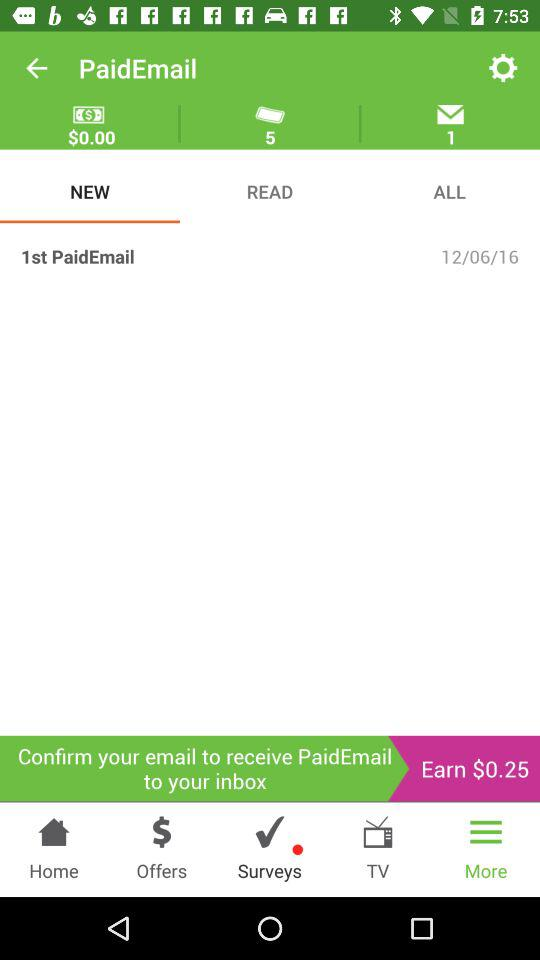When was the first paid email sent? The first paid email was sent on December 6, 2016. 